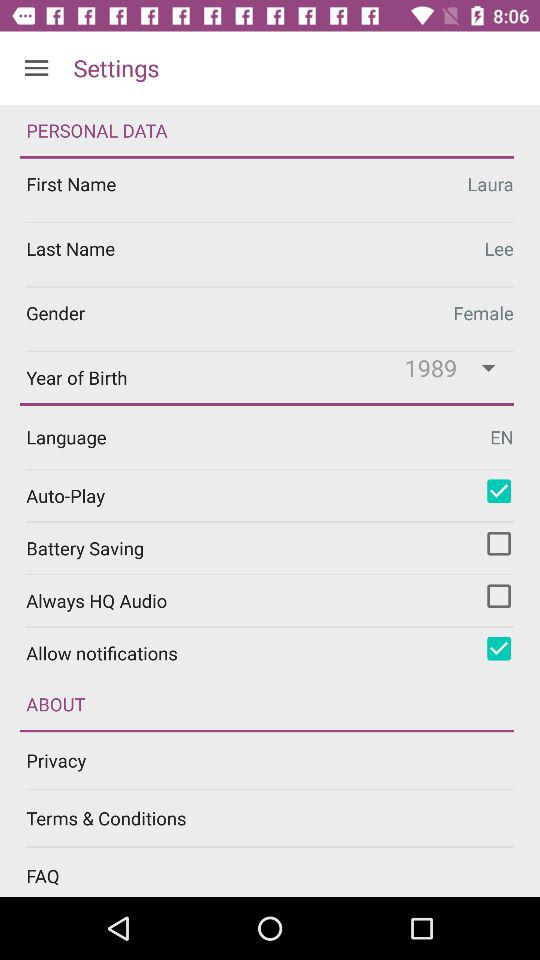What is the status of "Allow notifications"? The status of "Allow notifications" is "on". 